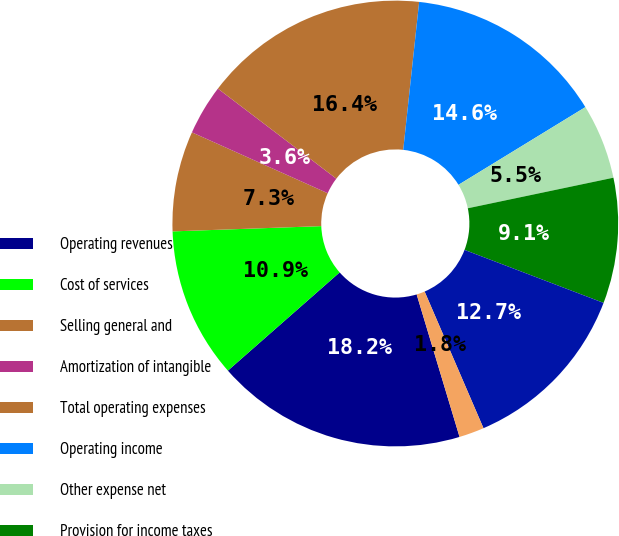<chart> <loc_0><loc_0><loc_500><loc_500><pie_chart><fcel>Operating revenues<fcel>Cost of services<fcel>Selling general and<fcel>Amortization of intangible<fcel>Total operating expenses<fcel>Operating income<fcel>Other expense net<fcel>Provision for income taxes<fcel>Net income<fcel>Earnings per basic common<nl><fcel>18.18%<fcel>10.91%<fcel>7.27%<fcel>3.64%<fcel>16.36%<fcel>14.55%<fcel>5.45%<fcel>9.09%<fcel>12.73%<fcel>1.82%<nl></chart> 